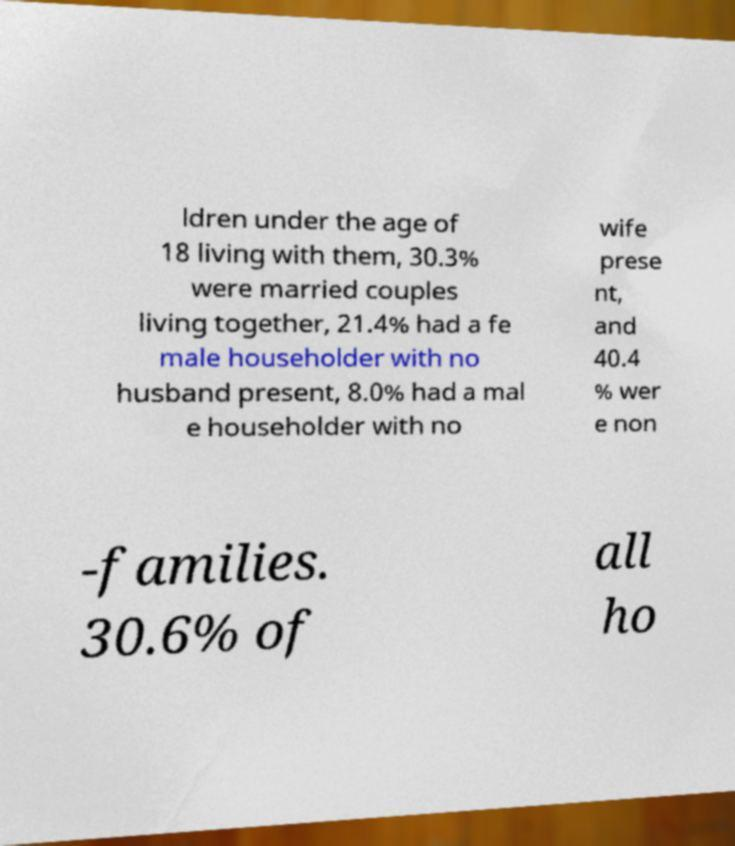I need the written content from this picture converted into text. Can you do that? ldren under the age of 18 living with them, 30.3% were married couples living together, 21.4% had a fe male householder with no husband present, 8.0% had a mal e householder with no wife prese nt, and 40.4 % wer e non -families. 30.6% of all ho 